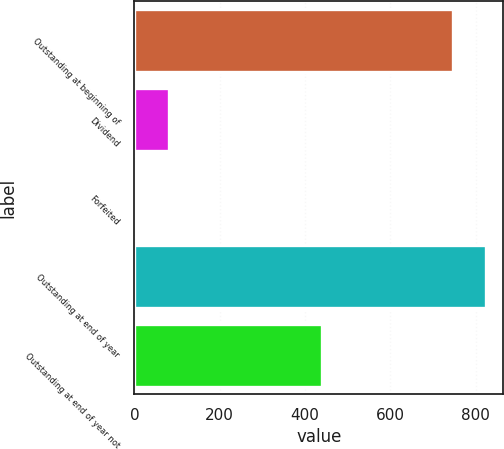<chart> <loc_0><loc_0><loc_500><loc_500><bar_chart><fcel>Outstanding at beginning of<fcel>Dividend<fcel>Forfeited<fcel>Outstanding at end of year<fcel>Outstanding at end of year not<nl><fcel>747<fcel>80.8<fcel>4<fcel>823.8<fcel>439<nl></chart> 